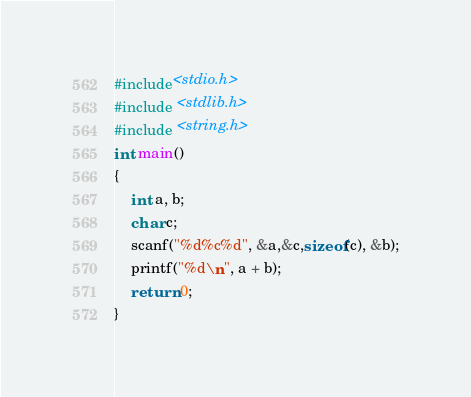<code> <loc_0><loc_0><loc_500><loc_500><_C_>#include<stdio.h>
#include <stdlib.h>
#include <string.h>
int main()
{
	int a, b;
	char c;
	scanf("%d%c%d", &a,&c,sizeof(c), &b);
	printf("%d\n", a + b);
	return 0;
}
</code> 